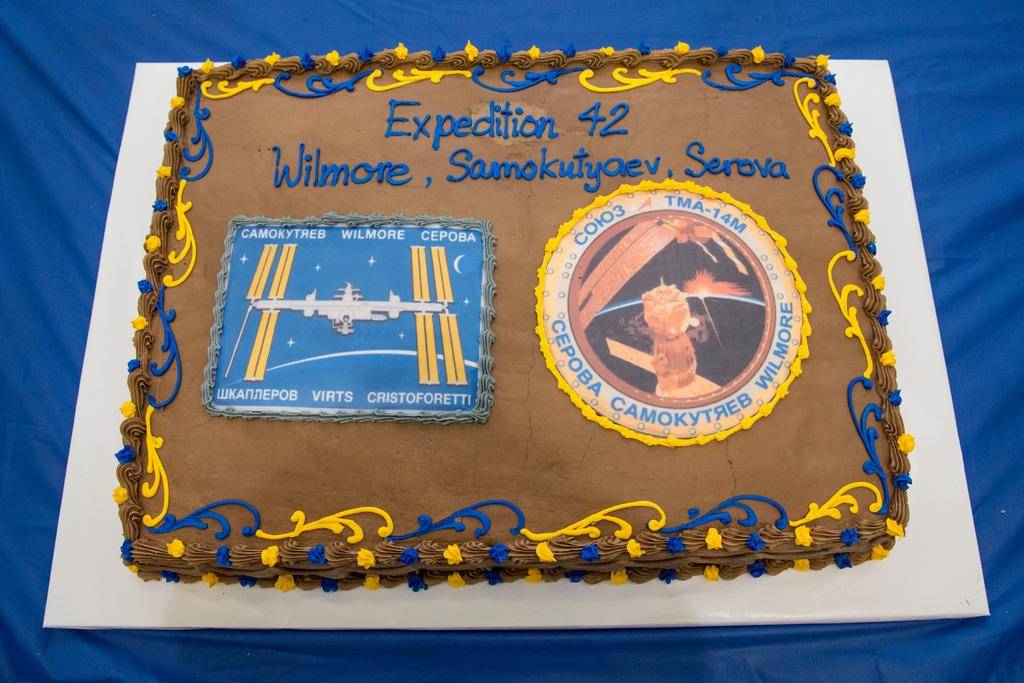What is the main subject of the image? There is a cake in the image. What is the cake placed on? The cake is on a blue color cloth. What is the color of the cake? The cake is brown in color. Is there any text or design on the cake? Yes, there is writing on the cake. What is the purpose of the mitten in the image? There is no mitten present in the image. 